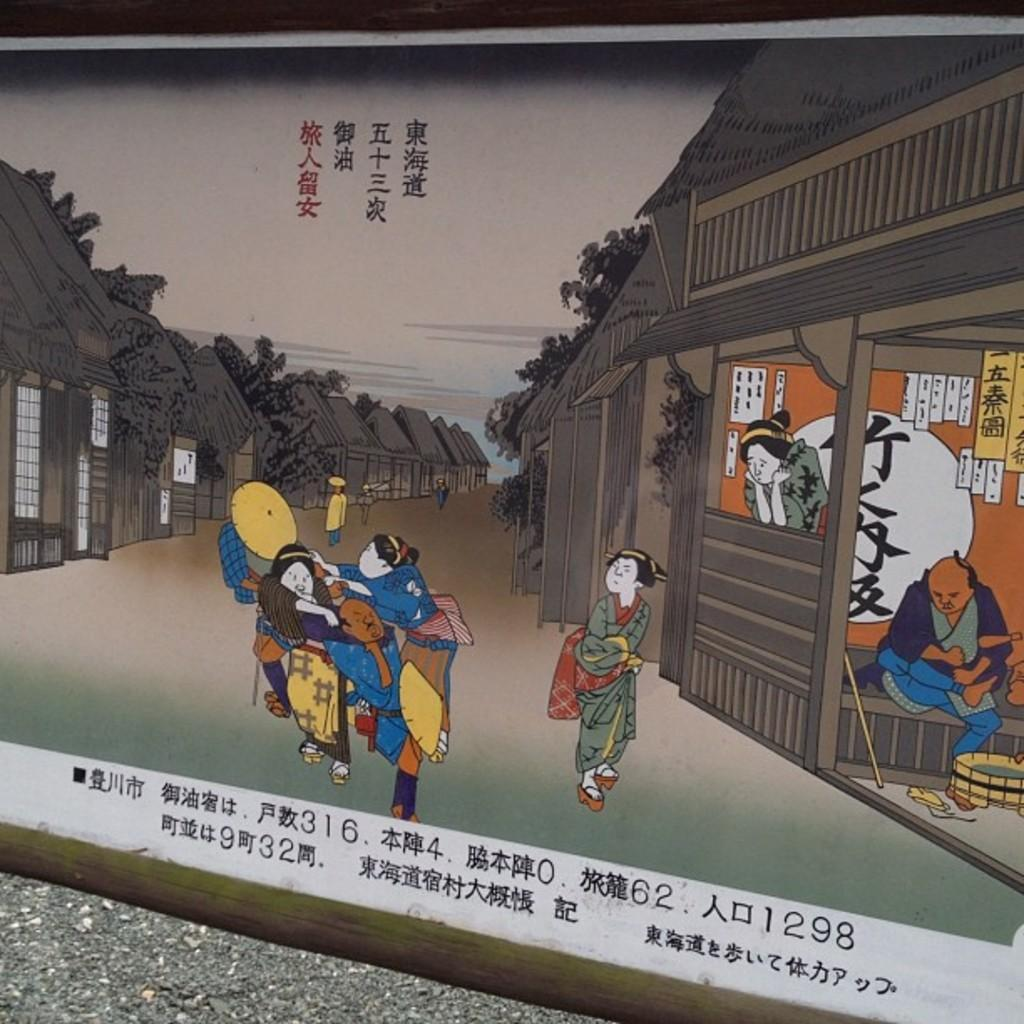What is depicted on the poster in the image? The poster contains a painting of people fighting. Can you describe the scene in the painting? In the painting, there is a man sitting on a bench. What else can be seen in the image besides the poster? There are buildings visible in the image. How many dinosaurs are present in the image? There are no dinosaurs present in the image. What type of respect can be seen between the people in the painting? The painting depicts people fighting, so there is no indication of respect between them. 